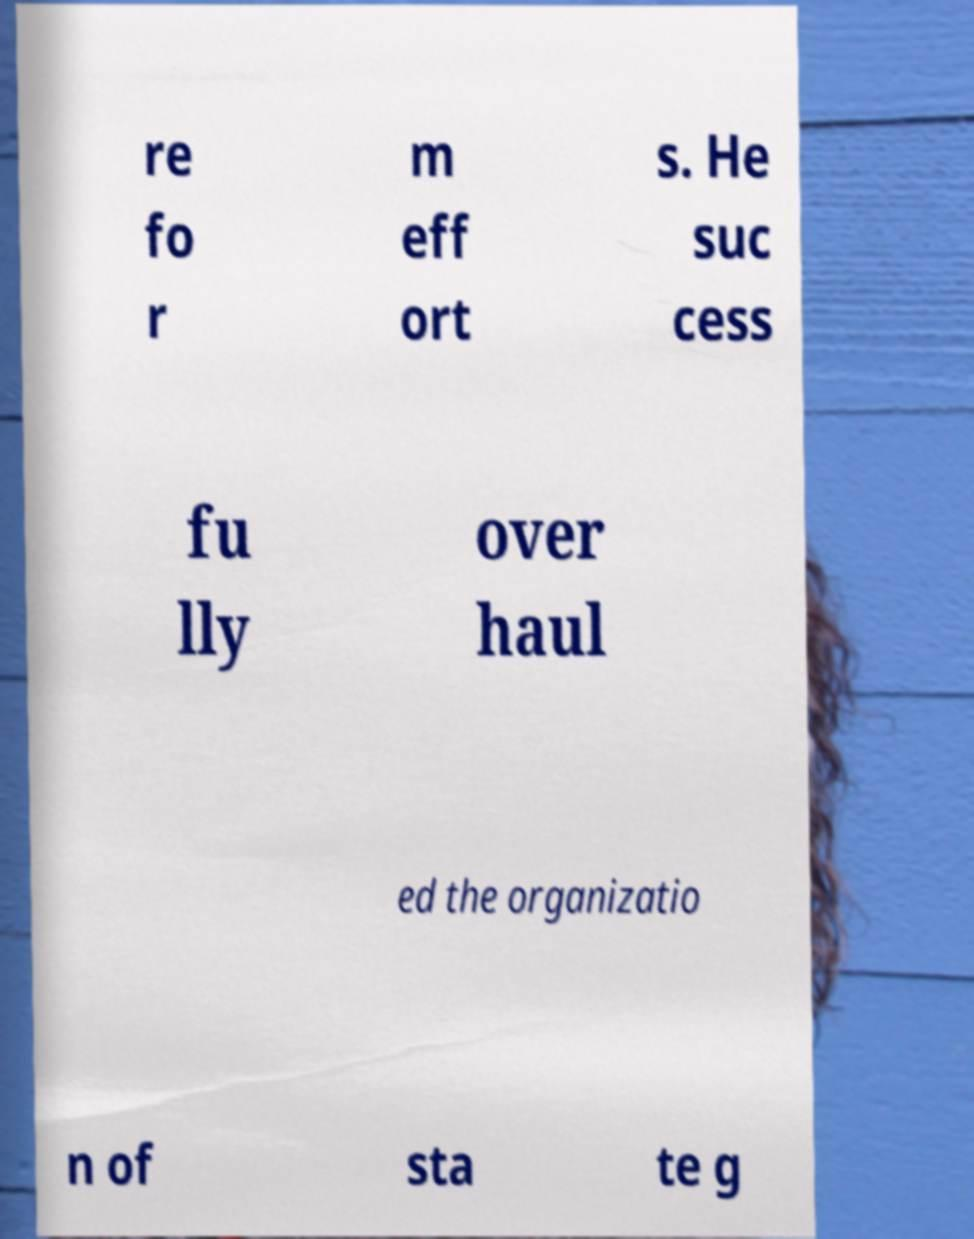Can you accurately transcribe the text from the provided image for me? re fo r m eff ort s. He suc cess fu lly over haul ed the organizatio n of sta te g 